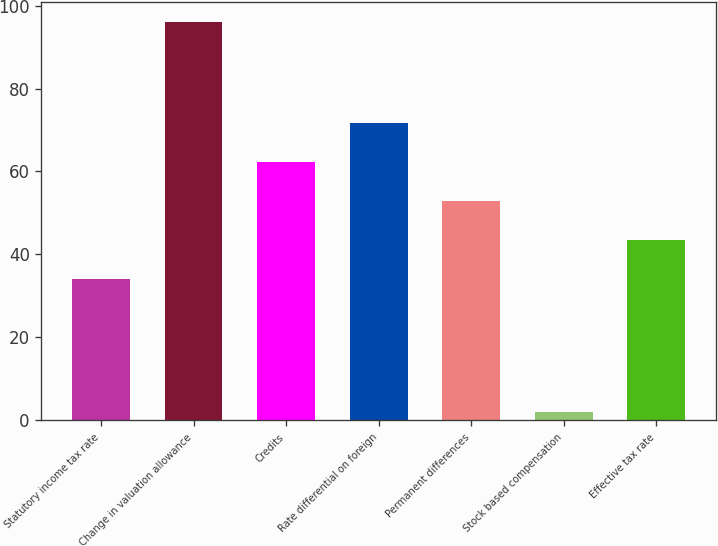Convert chart. <chart><loc_0><loc_0><loc_500><loc_500><bar_chart><fcel>Statutory income tax rate<fcel>Change in valuation allowance<fcel>Credits<fcel>Rate differential on foreign<fcel>Permanent differences<fcel>Stock based compensation<fcel>Effective tax rate<nl><fcel>34<fcel>96<fcel>62.2<fcel>71.6<fcel>52.8<fcel>2<fcel>43.4<nl></chart> 